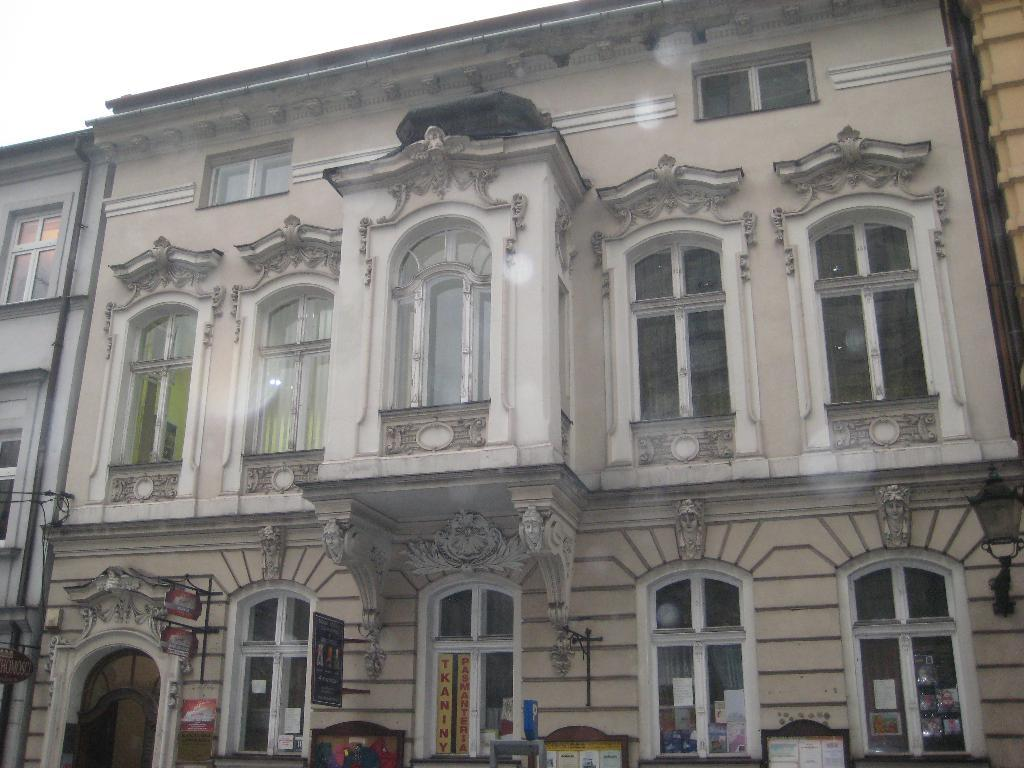What is the main subject in the middle of the picture? There is a building in the middle of the picture. What feature of the building is mentioned in the facts? The building has many windows. What can be seen in the background of the picture? There is sky visible in the background of the picture. What type of flesh can be seen hanging from the windows of the building in the image? There is no flesh present in the image; the building has many windows, but no flesh is mentioned or visible. 